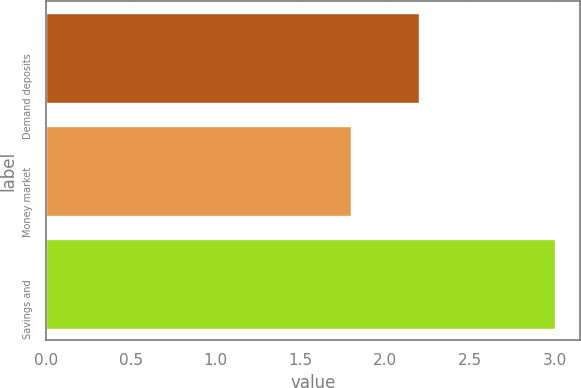Convert chart. <chart><loc_0><loc_0><loc_500><loc_500><bar_chart><fcel>Demand deposits<fcel>Money market<fcel>Savings and<nl><fcel>2.2<fcel>1.8<fcel>3<nl></chart> 